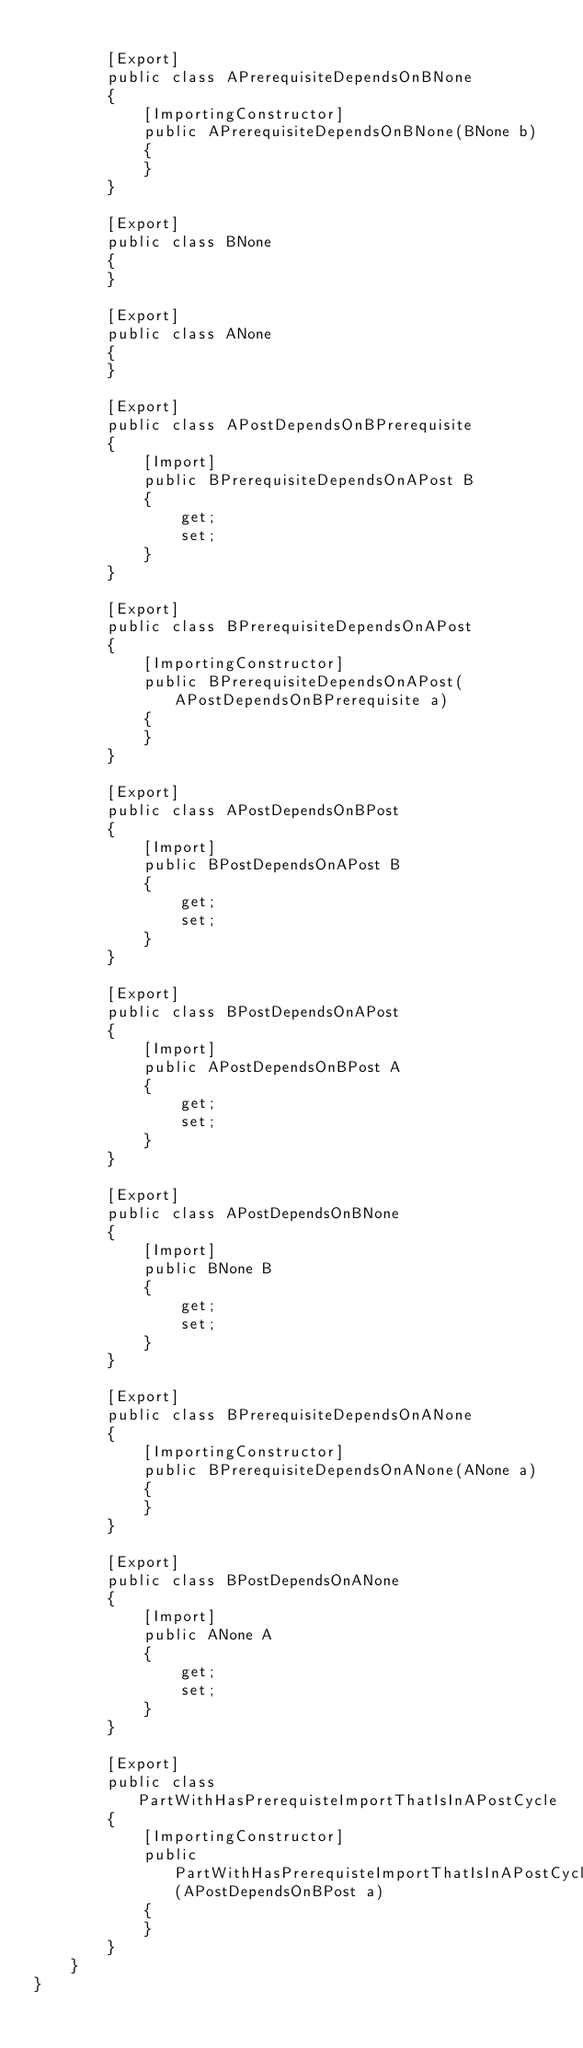<code> <loc_0><loc_0><loc_500><loc_500><_C#_>
        [Export]
        public class APrerequisiteDependsOnBNone
        {
            [ImportingConstructor]
            public APrerequisiteDependsOnBNone(BNone b)
            {
            }
        }

        [Export]
        public class BNone
        {
        }

        [Export]
        public class ANone
        {
        }

        [Export]
        public class APostDependsOnBPrerequisite
        {
            [Import]
            public BPrerequisiteDependsOnAPost B
            {
                get;
                set;
            }
        }

        [Export]
        public class BPrerequisiteDependsOnAPost
        {
            [ImportingConstructor]
            public BPrerequisiteDependsOnAPost(APostDependsOnBPrerequisite a)
            {
            }
        }

        [Export]
        public class APostDependsOnBPost
        {
            [Import]
            public BPostDependsOnAPost B
            {
                get;
                set;
            }
        }

        [Export]
        public class BPostDependsOnAPost
        {
            [Import]
            public APostDependsOnBPost A
            {
                get;
                set;
            }
        }

        [Export]
        public class APostDependsOnBNone
        {
            [Import]
            public BNone B
            {
                get;
                set;
            }
        }

        [Export]
        public class BPrerequisiteDependsOnANone
        {
            [ImportingConstructor]
            public BPrerequisiteDependsOnANone(ANone a)
            {
            }
        }

        [Export]
        public class BPostDependsOnANone
        {
            [Import]
            public ANone A
            {
                get;
                set;
            }
        }

        [Export]
        public class PartWithHasPrerequisteImportThatIsInAPostCycle
        {
            [ImportingConstructor]
            public PartWithHasPrerequisteImportThatIsInAPostCycle(APostDependsOnBPost a)
            {
            }
        }
    }
}
</code> 